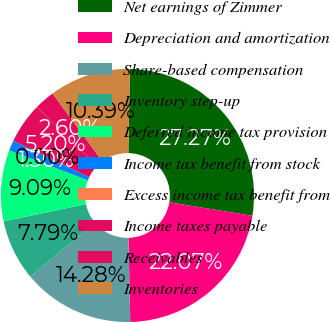Convert chart. <chart><loc_0><loc_0><loc_500><loc_500><pie_chart><fcel>Net earnings of Zimmer<fcel>Depreciation and amortization<fcel>Share-based compensation<fcel>Inventory step-up<fcel>Deferred income tax provision<fcel>Income tax benefit from stock<fcel>Excess income tax benefit from<fcel>Income taxes payable<fcel>Receivables<fcel>Inventories<nl><fcel>27.26%<fcel>22.07%<fcel>14.28%<fcel>7.79%<fcel>9.09%<fcel>1.3%<fcel>0.0%<fcel>5.2%<fcel>2.6%<fcel>10.39%<nl></chart> 